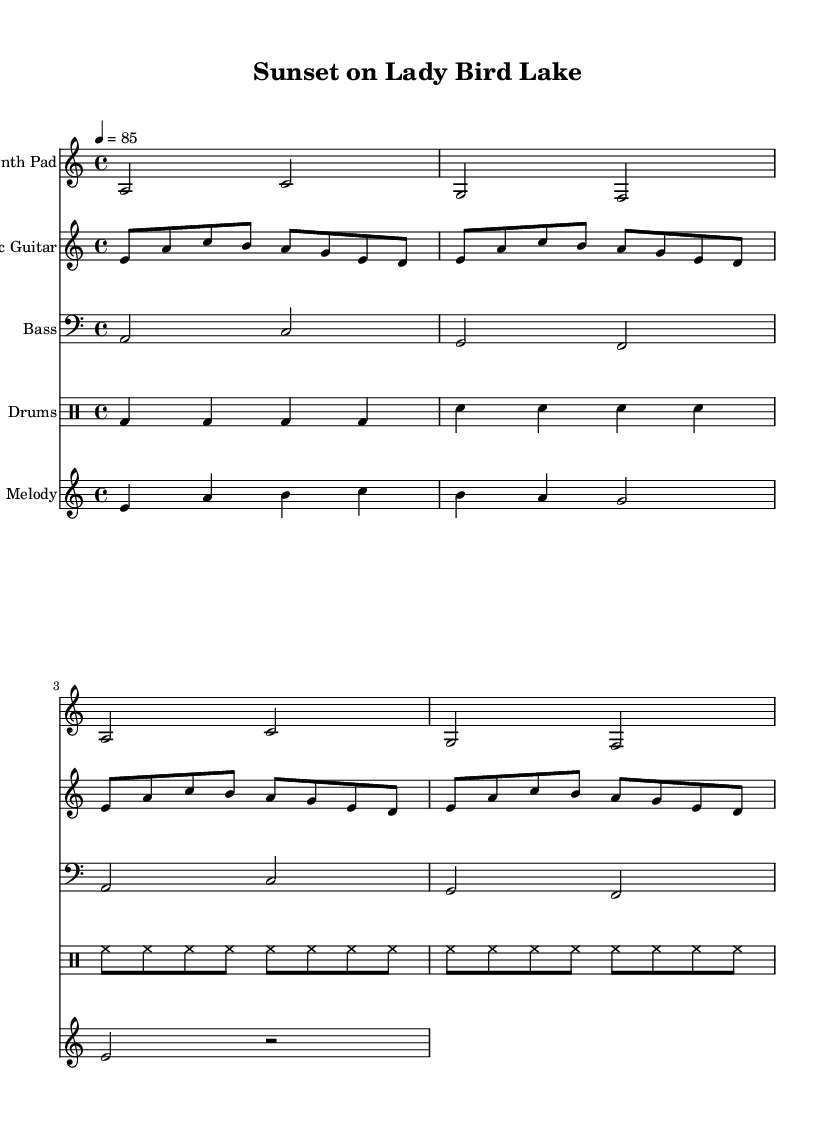What is the key signature of this music? The key signature is indicated at the beginning of the staff. In this case, it shows A minor, which has no sharps or flats.
Answer: A minor What is the time signature of the piece? The time signature appears at the beginning of the score, which displays 4/4, indicating four beats per measure.
Answer: 4/4 What is the tempo marking for this piece? The tempo marking is shown at the start of the music. Here it indicates a tempo of 85 beats per minute (4 = 85).
Answer: 85 How many measures are in the synth pad section? By counting the distinct segments divided by vertical lines, we see there are 4 measures in the synth pad section.
Answer: 4 Which instrument plays the melody? The instrument playing the melody is specified in the staff title. Here, it indicates "Melody," which refers to the instrument contributing the melodic line.
Answer: Melody What type of drums are represented in the drum pattern? The drum pattern shows different drum notations such as bass drum (bd), snare drum (sn), and hi-hat (hh) notations. This variety signifies the different types of drums being played.
Answer: Bass drum, snare drum, hi-hat What is the rhythmic structure of the electric guitar part? The electric guitar part features eighth notes and has a steady rhythm with a repeating pattern. It primarily consists of a consistent division of notes over the measures.
Answer: Eighth notes 